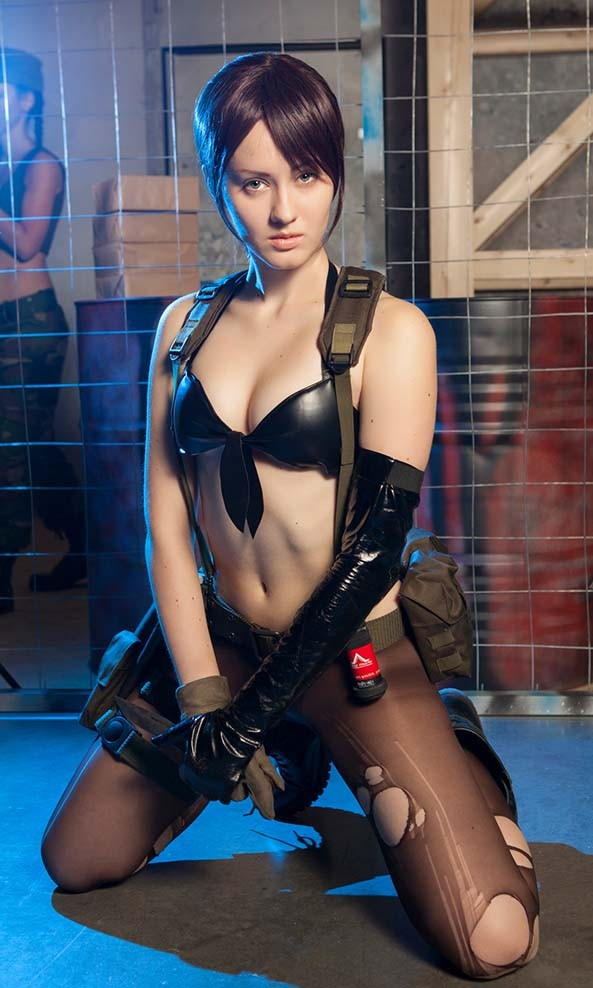The character seems to have a deliberate pose. What might that tell us about their personality or role? The character's pose, with a direct gaze and a grounded stance, exudes confidence and a sense of readiness. It's a display of strength and determination, suggesting a protagonist or a significant player in their narrative who's no stranger to confrontation. The open stance, despite the revealing nature of the outfit, could also imply a disregard for danger or a strategic use of their appearance as part of their arsenal, perhaps playing into themes of deception or seduction that are common in spy or noir genres. 